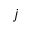<formula> <loc_0><loc_0><loc_500><loc_500>j</formula> 